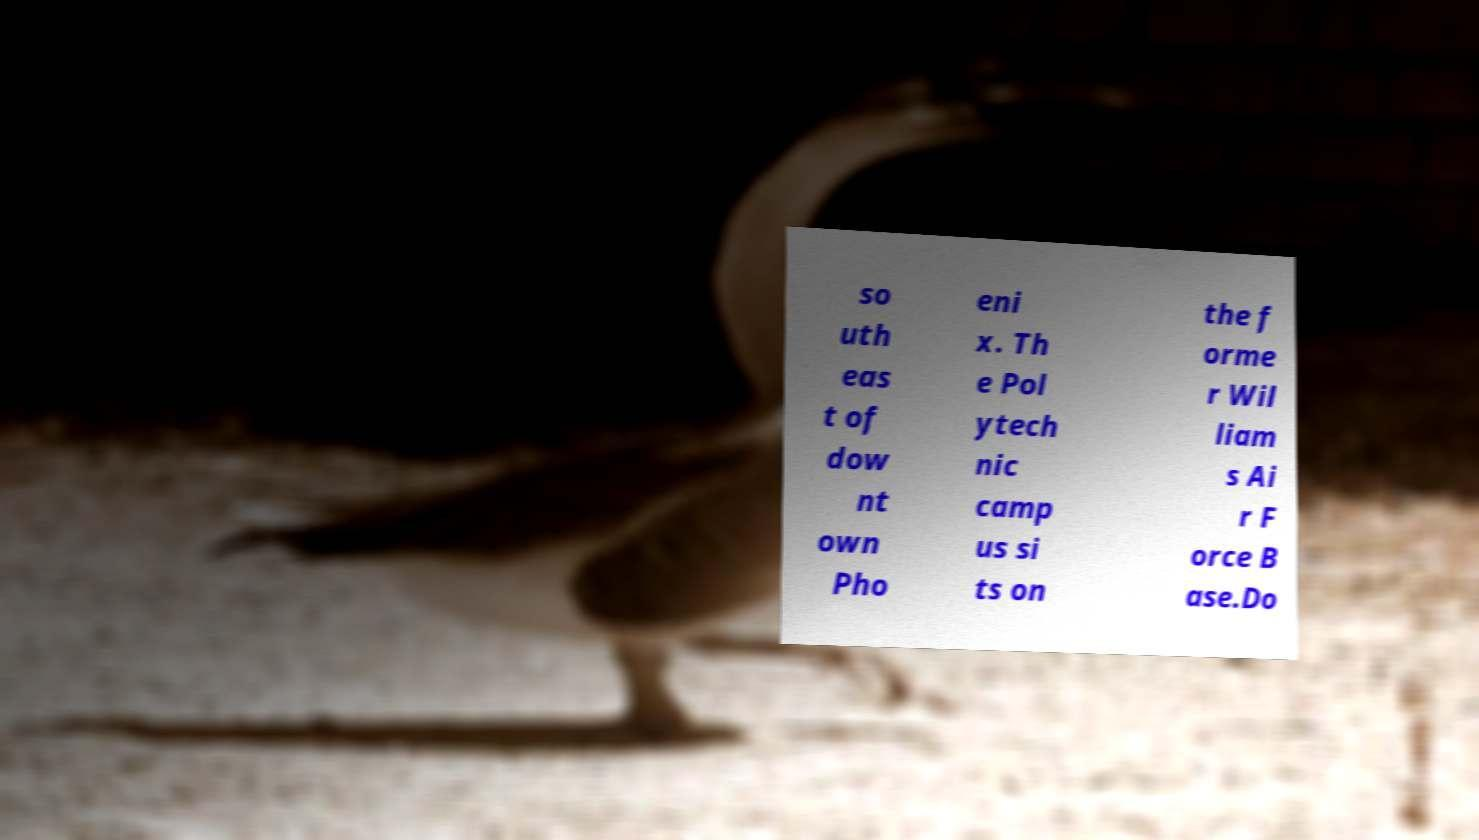What messages or text are displayed in this image? I need them in a readable, typed format. so uth eas t of dow nt own Pho eni x. Th e Pol ytech nic camp us si ts on the f orme r Wil liam s Ai r F orce B ase.Do 